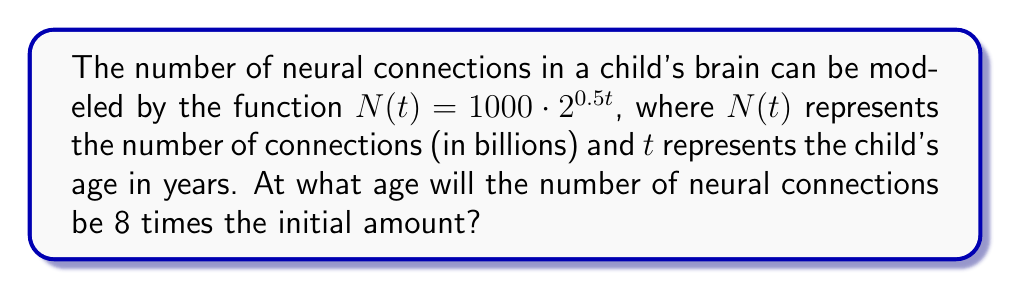Solve this math problem. Let's approach this step-by-step:

1) The initial number of connections (at t = 0) is:
   $N(0) = 1000 \cdot 2^{0.5 \cdot 0} = 1000$ billion

2) We want to find when the number of connections is 8 times this initial amount:
   $N(t) = 8 \cdot 1000 = 8000$ billion

3) Set up the equation:
   $8000 = 1000 \cdot 2^{0.5t}$

4) Divide both sides by 1000:
   $8 = 2^{0.5t}$

5) Take the logarithm (base 2) of both sides:
   $\log_2(8) = \log_2(2^{0.5t})$

6) Simplify the right side using the logarithm property $\log_a(a^x) = x$:
   $\log_2(8) = 0.5t$

7) Simplify the left side:
   $3 = 0.5t$

8) Multiply both sides by 2:
   $6 = t$

Therefore, the number of neural connections will be 8 times the initial amount when the child is 6 years old.
Answer: 6 years 